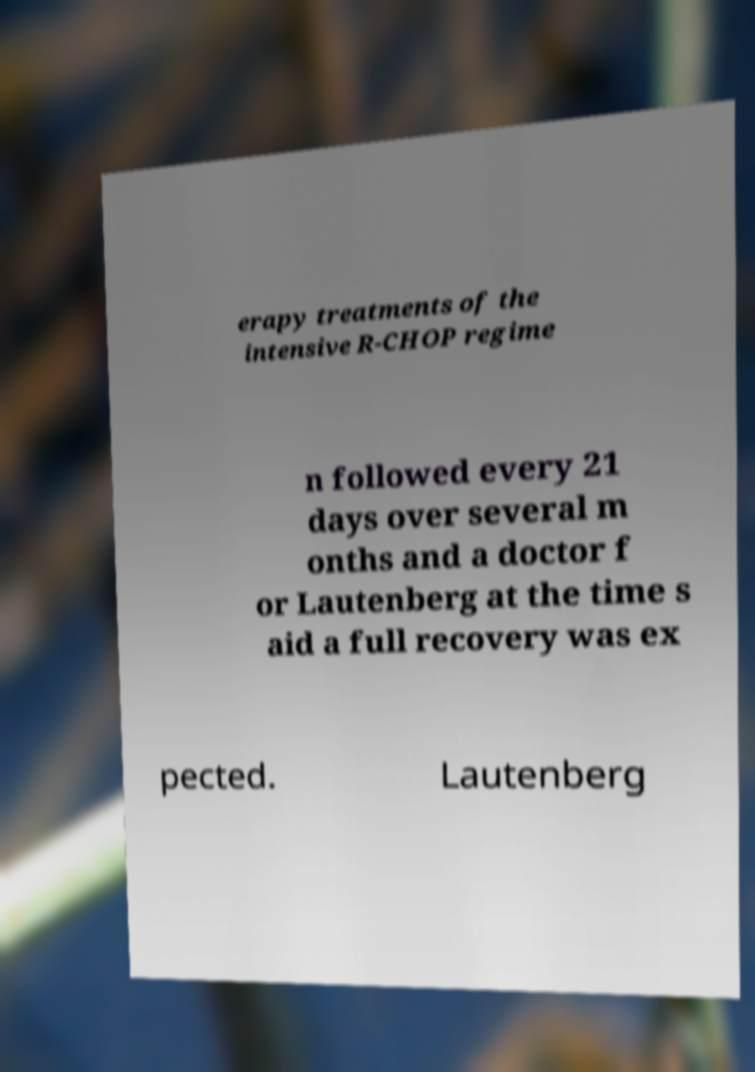There's text embedded in this image that I need extracted. Can you transcribe it verbatim? erapy treatments of the intensive R-CHOP regime n followed every 21 days over several m onths and a doctor f or Lautenberg at the time s aid a full recovery was ex pected. Lautenberg 